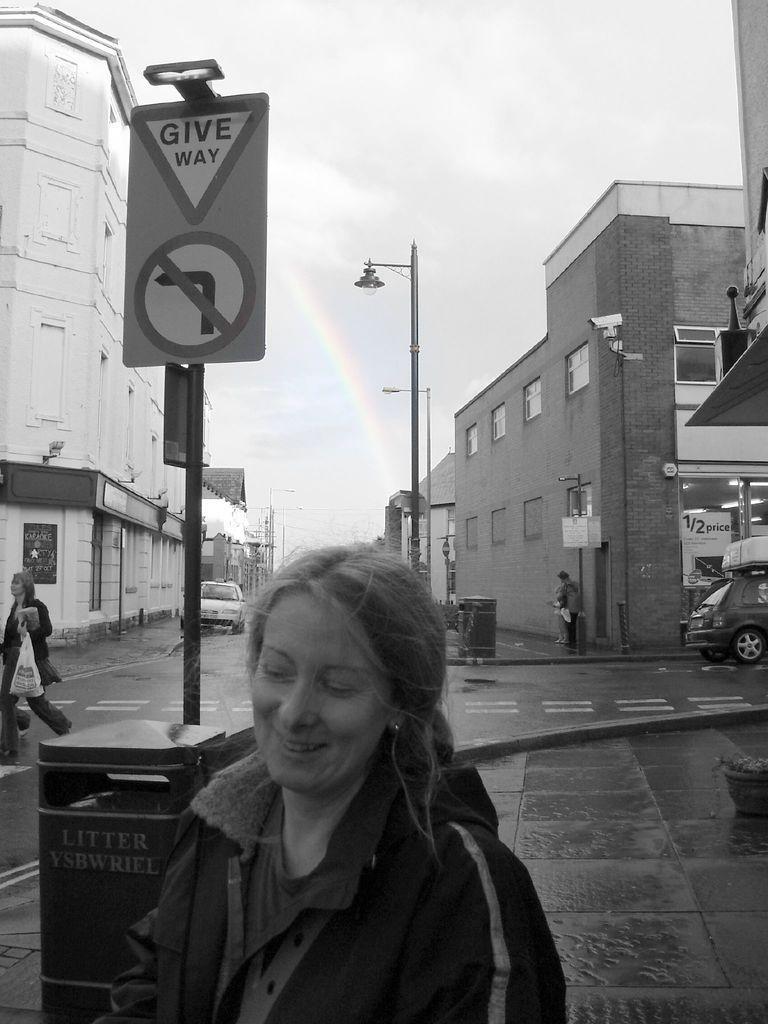Can you describe this image briefly? In this picture we can see people & vehicles on the road with sign boards and lamp posts. We can see buildings on either side. 